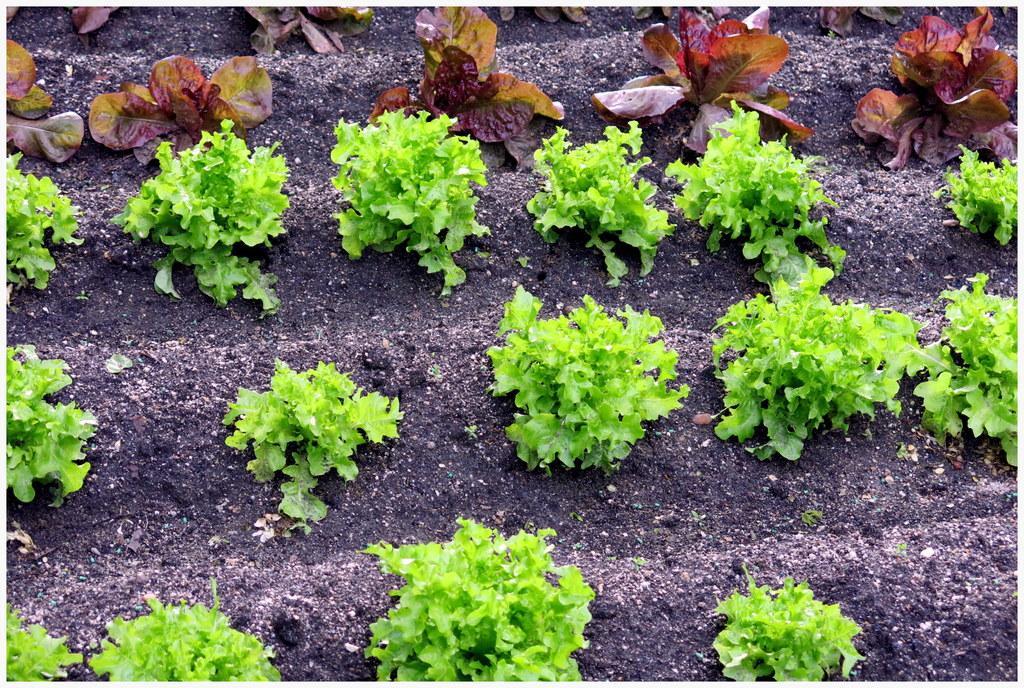Can you describe this image briefly? In this image we can see many plants. There is a black soil in the image. 